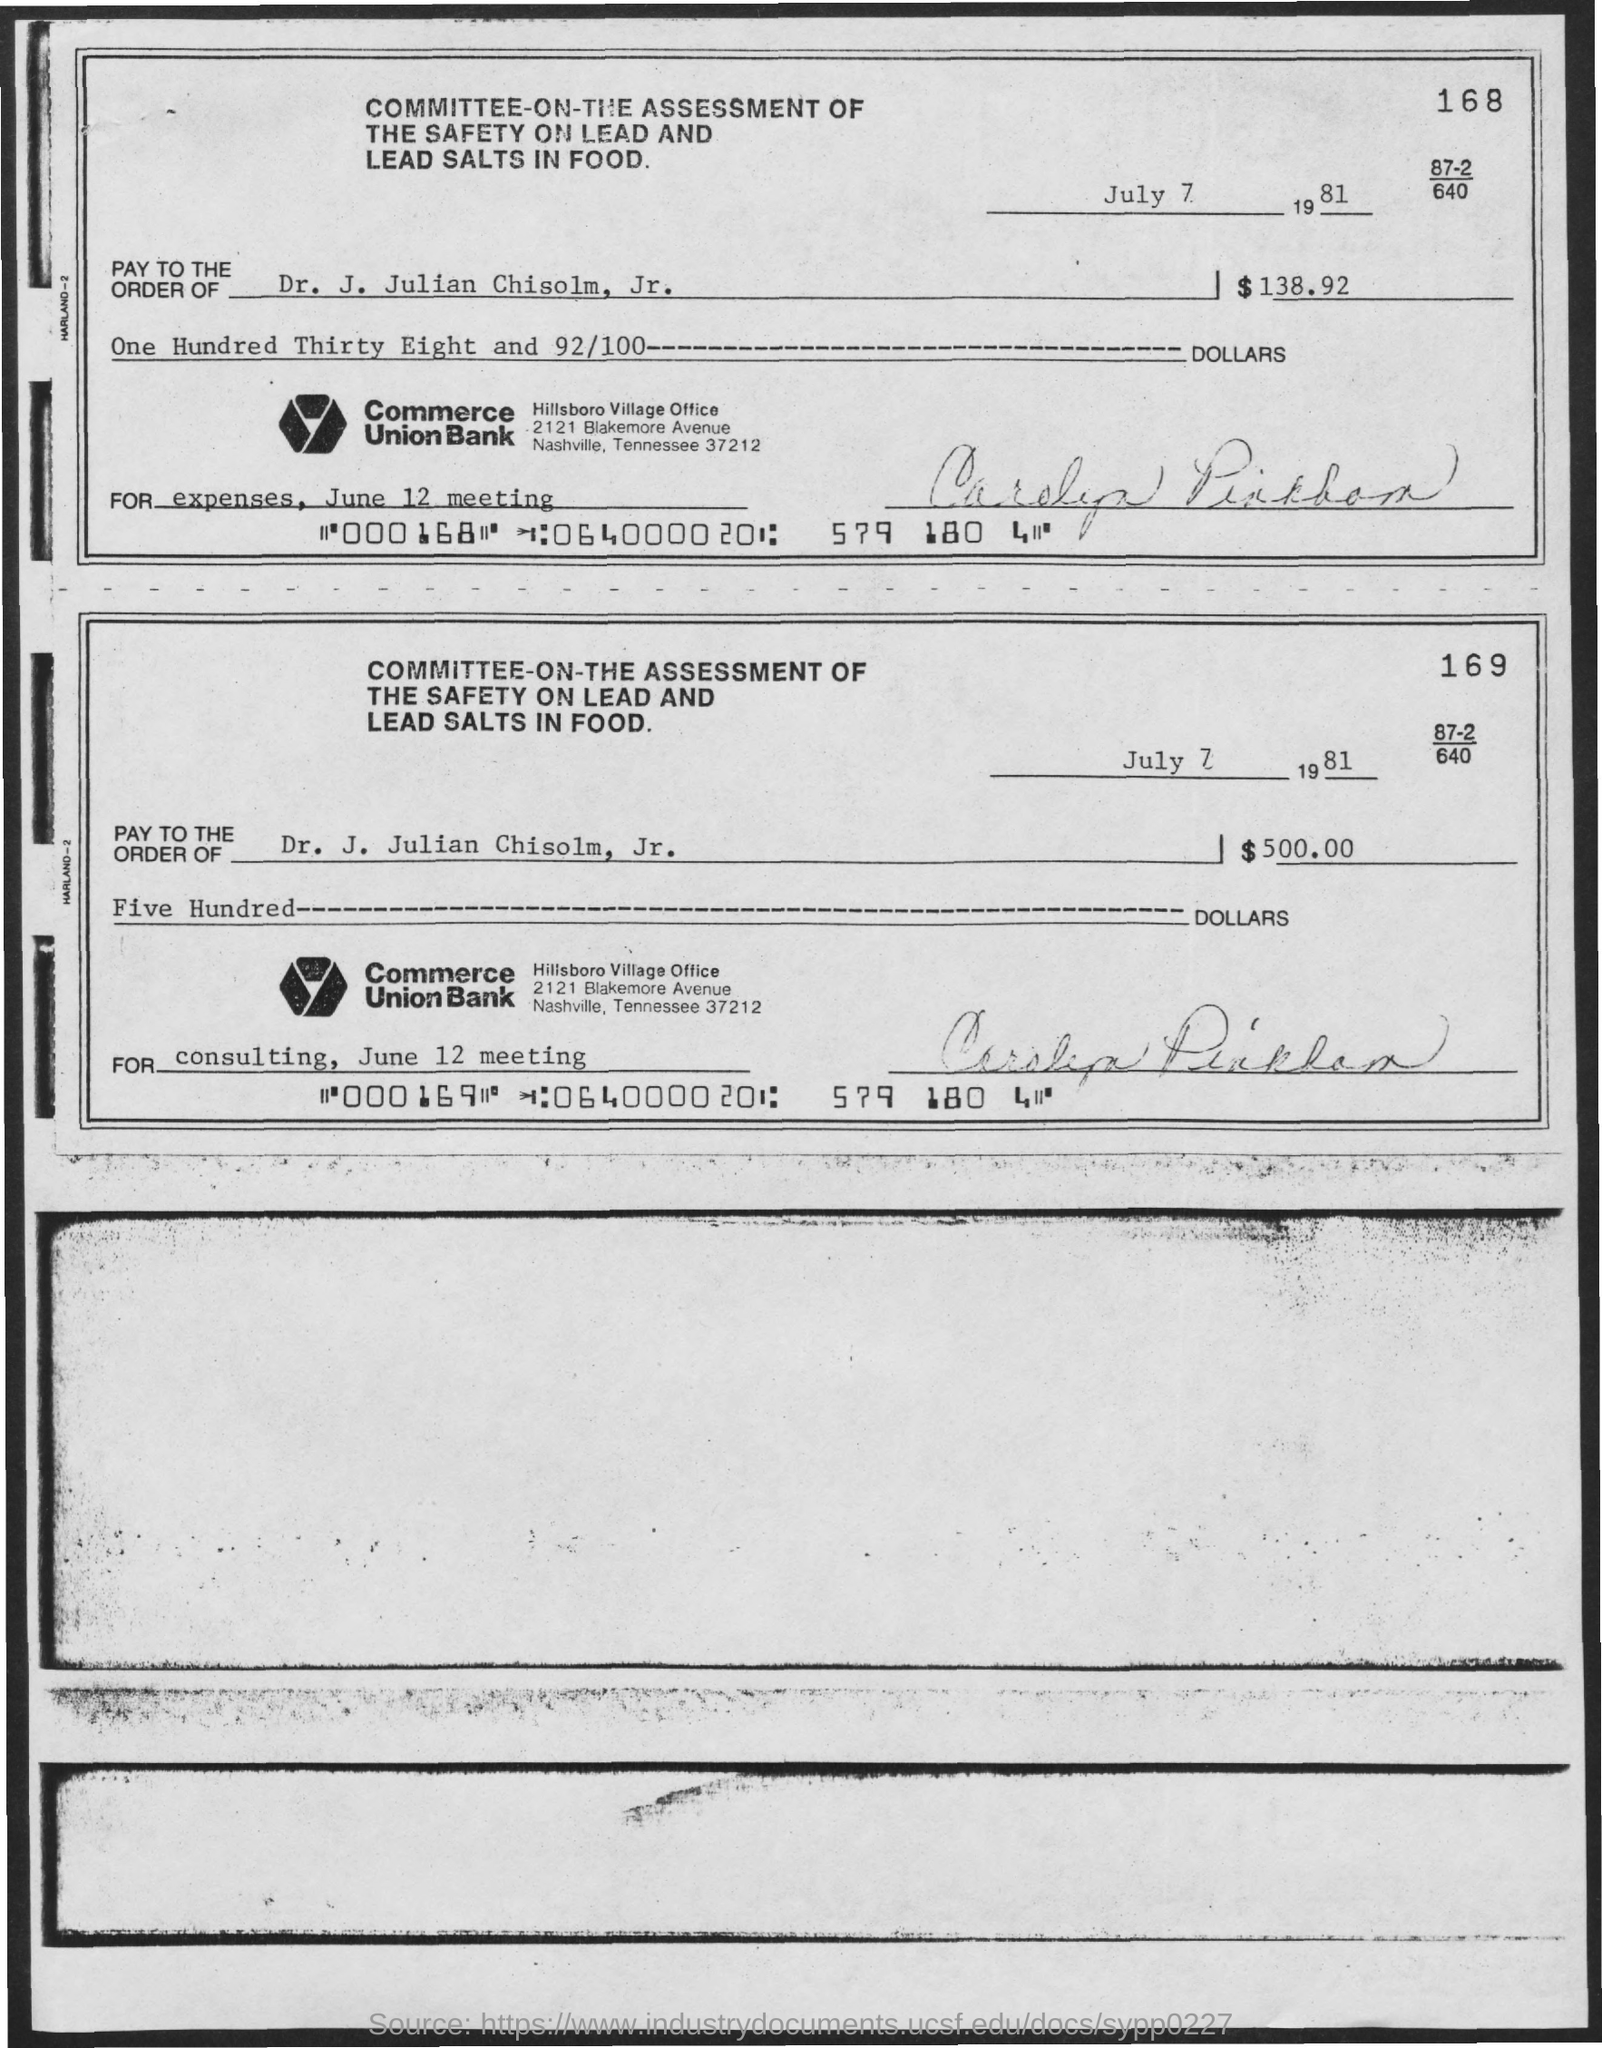When is the document dated?
Ensure brevity in your answer.  July 7 1981. What is the amount specified on check 168 in dollars?
Your response must be concise. $138.92. What is the amount for consulting, June 12 meeting in dollars?
Provide a short and direct response. $500.00. To whom should the checks be paid?
Ensure brevity in your answer.  DR. J. JULIAN CHISOLM, JR. 